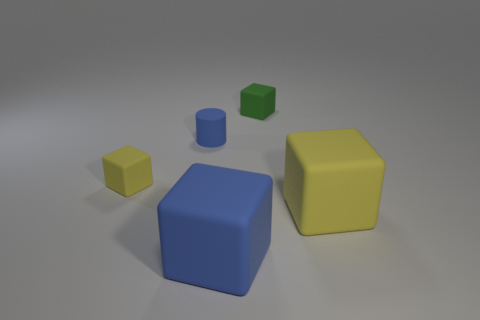Do the blue cylinder and the blue rubber block have the same size? No, they do not have the same size. The blue cylinder is shorter in height and has a smaller diameter compared to the dimensions of the blue rubber block, which appears to be larger in both height and width. 